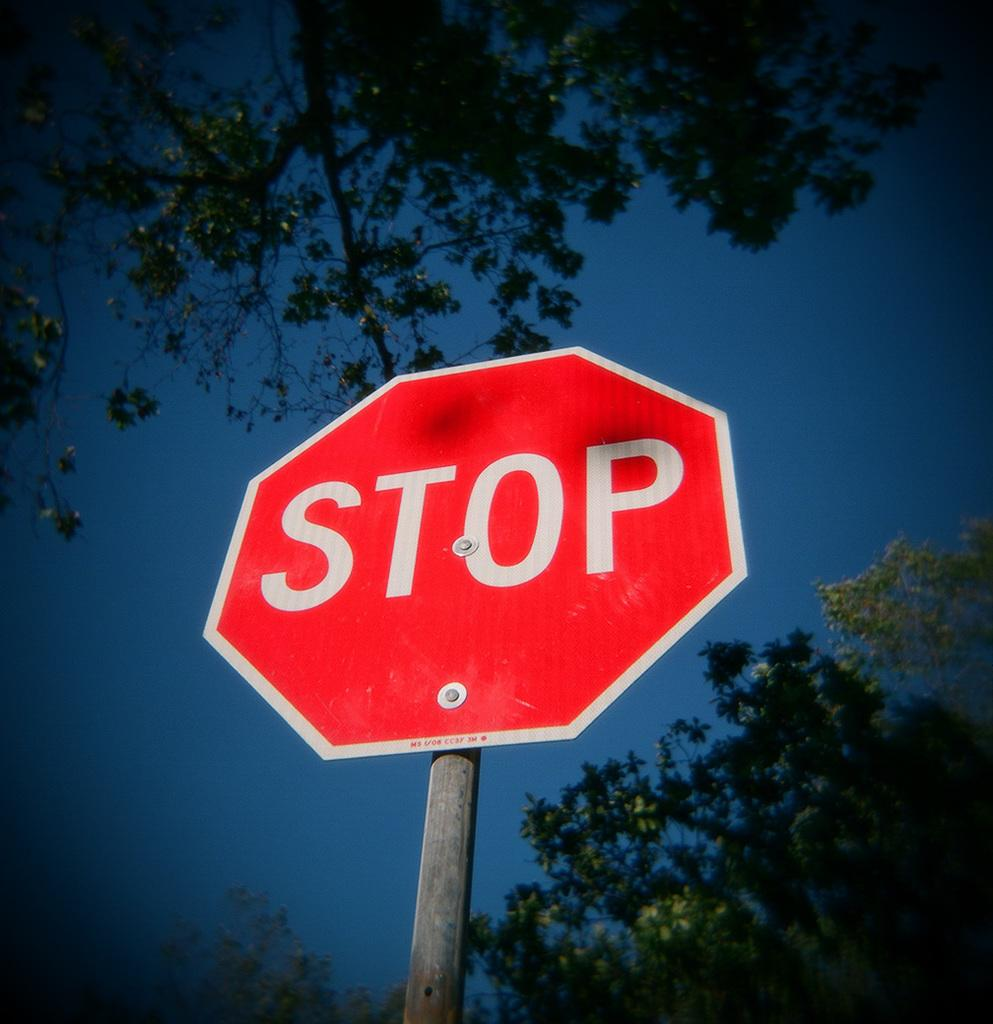<image>
Relay a brief, clear account of the picture shown. A stop sign against a blue sky with branches all around. 